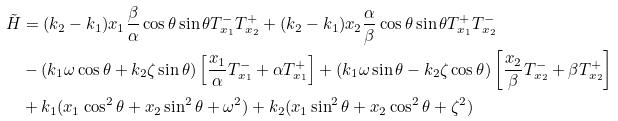Convert formula to latex. <formula><loc_0><loc_0><loc_500><loc_500>\tilde { H } & = ( k _ { 2 } - k _ { 1 } ) x _ { 1 } \frac { \beta } { \alpha } \cos \theta \sin \theta T _ { x _ { 1 } } ^ { - } T _ { x _ { 2 } } ^ { + } + ( k _ { 2 } - k _ { 1 } ) x _ { 2 } \frac { \alpha } { \beta } \cos \theta \sin \theta T _ { x _ { 1 } } ^ { + } T _ { x _ { 2 } } ^ { - } \\ & - ( k _ { 1 } \omega \cos \theta + k _ { 2 } \zeta \sin \theta ) \left [ \frac { x _ { 1 } } { \alpha } T _ { x _ { 1 } } ^ { - } + \alpha T _ { x _ { 1 } } ^ { + } \right ] + ( k _ { 1 } \omega \sin \theta - k _ { 2 } \zeta \cos \theta ) \left [ \frac { x _ { 2 } } { \beta } T _ { x _ { 2 } } ^ { - } + \beta T _ { x _ { 2 } } ^ { + } \right ] \\ & + k _ { 1 } ( x _ { 1 } \cos ^ { 2 } \theta + x _ { 2 } \sin ^ { 2 } \theta + \omega ^ { 2 } ) + k _ { 2 } ( x _ { 1 } \sin ^ { 2 } \theta + x _ { 2 } \cos ^ { 2 } \theta + \zeta ^ { 2 } )</formula> 